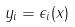<formula> <loc_0><loc_0><loc_500><loc_500>y _ { i } = \epsilon _ { i } ( x )</formula> 